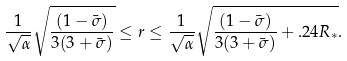Convert formula to latex. <formula><loc_0><loc_0><loc_500><loc_500>\frac { 1 } { \sqrt { \alpha } } \sqrt { \frac { ( 1 - \bar { \sigma } ) } { 3 ( 3 + \bar { \sigma } ) } } \leq r \leq \frac { 1 } { \sqrt { \alpha } } \sqrt { \frac { ( 1 - \bar { \sigma } ) } { 3 ( 3 + \bar { \sigma } ) } + . 2 4 R _ { * } } .</formula> 